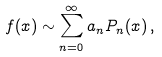Convert formula to latex. <formula><loc_0><loc_0><loc_500><loc_500>f ( x ) \sim \sum _ { n = 0 } ^ { \infty } a _ { n } P _ { n } ( x ) \, ,</formula> 